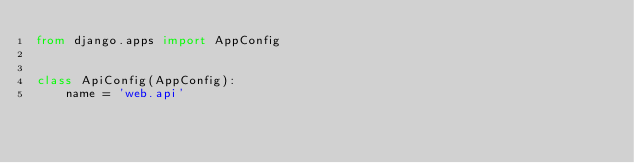<code> <loc_0><loc_0><loc_500><loc_500><_Python_>from django.apps import AppConfig


class ApiConfig(AppConfig):
    name = 'web.api'
</code> 